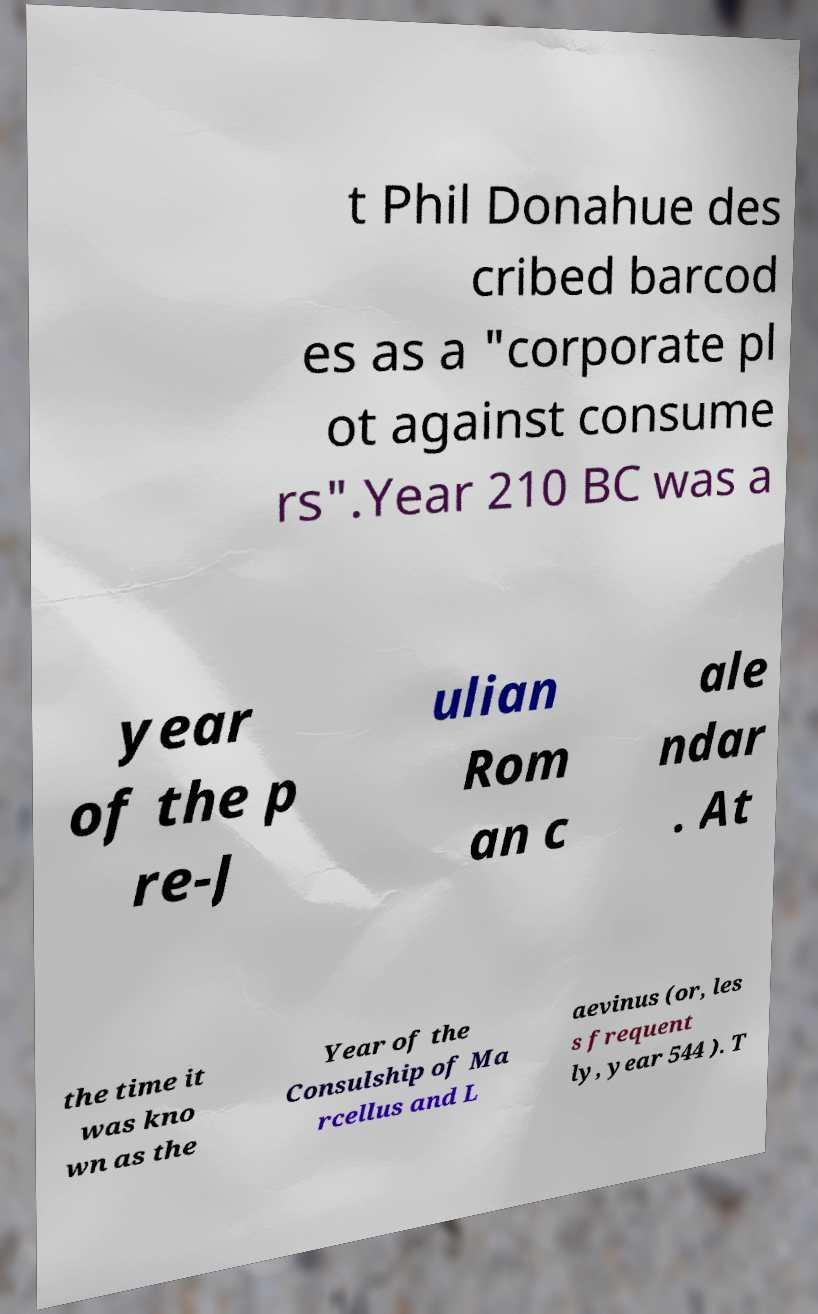There's text embedded in this image that I need extracted. Can you transcribe it verbatim? t Phil Donahue des cribed barcod es as a "corporate pl ot against consume rs".Year 210 BC was a year of the p re-J ulian Rom an c ale ndar . At the time it was kno wn as the Year of the Consulship of Ma rcellus and L aevinus (or, les s frequent ly, year 544 ). T 